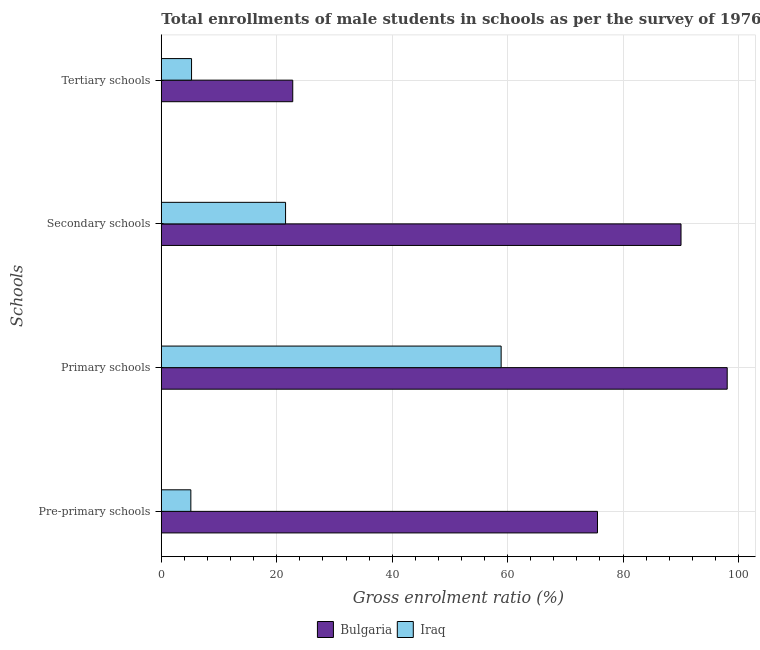How many different coloured bars are there?
Make the answer very short. 2. Are the number of bars per tick equal to the number of legend labels?
Your answer should be very brief. Yes. How many bars are there on the 4th tick from the top?
Your response must be concise. 2. What is the label of the 3rd group of bars from the top?
Provide a short and direct response. Primary schools. What is the gross enrolment ratio(male) in secondary schools in Bulgaria?
Your answer should be compact. 90.04. Across all countries, what is the maximum gross enrolment ratio(male) in tertiary schools?
Give a very brief answer. 22.77. Across all countries, what is the minimum gross enrolment ratio(male) in pre-primary schools?
Give a very brief answer. 5.12. In which country was the gross enrolment ratio(male) in pre-primary schools maximum?
Your response must be concise. Bulgaria. In which country was the gross enrolment ratio(male) in tertiary schools minimum?
Provide a short and direct response. Iraq. What is the total gross enrolment ratio(male) in pre-primary schools in the graph?
Offer a very short reply. 80.69. What is the difference between the gross enrolment ratio(male) in tertiary schools in Iraq and that in Bulgaria?
Your answer should be compact. -17.53. What is the difference between the gross enrolment ratio(male) in primary schools in Bulgaria and the gross enrolment ratio(male) in secondary schools in Iraq?
Your answer should be compact. 76.52. What is the average gross enrolment ratio(male) in secondary schools per country?
Offer a terse response. 55.79. What is the difference between the gross enrolment ratio(male) in tertiary schools and gross enrolment ratio(male) in pre-primary schools in Iraq?
Give a very brief answer. 0.12. What is the ratio of the gross enrolment ratio(male) in pre-primary schools in Bulgaria to that in Iraq?
Make the answer very short. 14.77. Is the difference between the gross enrolment ratio(male) in pre-primary schools in Iraq and Bulgaria greater than the difference between the gross enrolment ratio(male) in tertiary schools in Iraq and Bulgaria?
Give a very brief answer. No. What is the difference between the highest and the second highest gross enrolment ratio(male) in tertiary schools?
Offer a terse response. 17.53. What is the difference between the highest and the lowest gross enrolment ratio(male) in pre-primary schools?
Ensure brevity in your answer.  70.45. In how many countries, is the gross enrolment ratio(male) in primary schools greater than the average gross enrolment ratio(male) in primary schools taken over all countries?
Make the answer very short. 1. Is it the case that in every country, the sum of the gross enrolment ratio(male) in pre-primary schools and gross enrolment ratio(male) in primary schools is greater than the sum of gross enrolment ratio(male) in tertiary schools and gross enrolment ratio(male) in secondary schools?
Give a very brief answer. Yes. Is it the case that in every country, the sum of the gross enrolment ratio(male) in pre-primary schools and gross enrolment ratio(male) in primary schools is greater than the gross enrolment ratio(male) in secondary schools?
Your response must be concise. Yes. How many bars are there?
Offer a terse response. 8. How many countries are there in the graph?
Provide a short and direct response. 2. What is the difference between two consecutive major ticks on the X-axis?
Offer a terse response. 20. Are the values on the major ticks of X-axis written in scientific E-notation?
Ensure brevity in your answer.  No. Does the graph contain any zero values?
Provide a succinct answer. No. Does the graph contain grids?
Your answer should be very brief. Yes. Where does the legend appear in the graph?
Make the answer very short. Bottom center. How many legend labels are there?
Your answer should be very brief. 2. What is the title of the graph?
Provide a succinct answer. Total enrollments of male students in schools as per the survey of 1976 conducted in different countries. Does "Channel Islands" appear as one of the legend labels in the graph?
Provide a succinct answer. No. What is the label or title of the X-axis?
Provide a short and direct response. Gross enrolment ratio (%). What is the label or title of the Y-axis?
Provide a short and direct response. Schools. What is the Gross enrolment ratio (%) of Bulgaria in Pre-primary schools?
Make the answer very short. 75.57. What is the Gross enrolment ratio (%) of Iraq in Pre-primary schools?
Ensure brevity in your answer.  5.12. What is the Gross enrolment ratio (%) in Bulgaria in Primary schools?
Offer a very short reply. 98.04. What is the Gross enrolment ratio (%) in Iraq in Primary schools?
Provide a short and direct response. 58.88. What is the Gross enrolment ratio (%) of Bulgaria in Secondary schools?
Your response must be concise. 90.04. What is the Gross enrolment ratio (%) in Iraq in Secondary schools?
Offer a terse response. 21.53. What is the Gross enrolment ratio (%) of Bulgaria in Tertiary schools?
Provide a short and direct response. 22.77. What is the Gross enrolment ratio (%) in Iraq in Tertiary schools?
Make the answer very short. 5.24. Across all Schools, what is the maximum Gross enrolment ratio (%) of Bulgaria?
Provide a succinct answer. 98.04. Across all Schools, what is the maximum Gross enrolment ratio (%) in Iraq?
Keep it short and to the point. 58.88. Across all Schools, what is the minimum Gross enrolment ratio (%) of Bulgaria?
Keep it short and to the point. 22.77. Across all Schools, what is the minimum Gross enrolment ratio (%) in Iraq?
Your response must be concise. 5.12. What is the total Gross enrolment ratio (%) of Bulgaria in the graph?
Ensure brevity in your answer.  286.43. What is the total Gross enrolment ratio (%) of Iraq in the graph?
Make the answer very short. 90.76. What is the difference between the Gross enrolment ratio (%) of Bulgaria in Pre-primary schools and that in Primary schools?
Your response must be concise. -22.47. What is the difference between the Gross enrolment ratio (%) in Iraq in Pre-primary schools and that in Primary schools?
Your answer should be compact. -53.76. What is the difference between the Gross enrolment ratio (%) in Bulgaria in Pre-primary schools and that in Secondary schools?
Provide a short and direct response. -14.47. What is the difference between the Gross enrolment ratio (%) in Iraq in Pre-primary schools and that in Secondary schools?
Provide a succinct answer. -16.41. What is the difference between the Gross enrolment ratio (%) of Bulgaria in Pre-primary schools and that in Tertiary schools?
Make the answer very short. 52.8. What is the difference between the Gross enrolment ratio (%) of Iraq in Pre-primary schools and that in Tertiary schools?
Keep it short and to the point. -0.12. What is the difference between the Gross enrolment ratio (%) in Bulgaria in Primary schools and that in Secondary schools?
Keep it short and to the point. 8. What is the difference between the Gross enrolment ratio (%) in Iraq in Primary schools and that in Secondary schools?
Ensure brevity in your answer.  37.35. What is the difference between the Gross enrolment ratio (%) of Bulgaria in Primary schools and that in Tertiary schools?
Keep it short and to the point. 75.27. What is the difference between the Gross enrolment ratio (%) of Iraq in Primary schools and that in Tertiary schools?
Provide a succinct answer. 53.64. What is the difference between the Gross enrolment ratio (%) in Bulgaria in Secondary schools and that in Tertiary schools?
Offer a very short reply. 67.27. What is the difference between the Gross enrolment ratio (%) of Iraq in Secondary schools and that in Tertiary schools?
Provide a succinct answer. 16.29. What is the difference between the Gross enrolment ratio (%) of Bulgaria in Pre-primary schools and the Gross enrolment ratio (%) of Iraq in Primary schools?
Ensure brevity in your answer.  16.69. What is the difference between the Gross enrolment ratio (%) in Bulgaria in Pre-primary schools and the Gross enrolment ratio (%) in Iraq in Secondary schools?
Your answer should be very brief. 54.04. What is the difference between the Gross enrolment ratio (%) in Bulgaria in Pre-primary schools and the Gross enrolment ratio (%) in Iraq in Tertiary schools?
Offer a terse response. 70.33. What is the difference between the Gross enrolment ratio (%) in Bulgaria in Primary schools and the Gross enrolment ratio (%) in Iraq in Secondary schools?
Your answer should be compact. 76.52. What is the difference between the Gross enrolment ratio (%) of Bulgaria in Primary schools and the Gross enrolment ratio (%) of Iraq in Tertiary schools?
Your answer should be very brief. 92.81. What is the difference between the Gross enrolment ratio (%) of Bulgaria in Secondary schools and the Gross enrolment ratio (%) of Iraq in Tertiary schools?
Provide a short and direct response. 84.81. What is the average Gross enrolment ratio (%) of Bulgaria per Schools?
Provide a short and direct response. 71.61. What is the average Gross enrolment ratio (%) in Iraq per Schools?
Ensure brevity in your answer.  22.69. What is the difference between the Gross enrolment ratio (%) of Bulgaria and Gross enrolment ratio (%) of Iraq in Pre-primary schools?
Your answer should be very brief. 70.45. What is the difference between the Gross enrolment ratio (%) of Bulgaria and Gross enrolment ratio (%) of Iraq in Primary schools?
Offer a very short reply. 39.17. What is the difference between the Gross enrolment ratio (%) of Bulgaria and Gross enrolment ratio (%) of Iraq in Secondary schools?
Your response must be concise. 68.52. What is the difference between the Gross enrolment ratio (%) of Bulgaria and Gross enrolment ratio (%) of Iraq in Tertiary schools?
Keep it short and to the point. 17.53. What is the ratio of the Gross enrolment ratio (%) in Bulgaria in Pre-primary schools to that in Primary schools?
Keep it short and to the point. 0.77. What is the ratio of the Gross enrolment ratio (%) in Iraq in Pre-primary schools to that in Primary schools?
Provide a short and direct response. 0.09. What is the ratio of the Gross enrolment ratio (%) in Bulgaria in Pre-primary schools to that in Secondary schools?
Your answer should be compact. 0.84. What is the ratio of the Gross enrolment ratio (%) in Iraq in Pre-primary schools to that in Secondary schools?
Your response must be concise. 0.24. What is the ratio of the Gross enrolment ratio (%) of Bulgaria in Pre-primary schools to that in Tertiary schools?
Your answer should be compact. 3.32. What is the ratio of the Gross enrolment ratio (%) of Iraq in Pre-primary schools to that in Tertiary schools?
Offer a terse response. 0.98. What is the ratio of the Gross enrolment ratio (%) of Bulgaria in Primary schools to that in Secondary schools?
Your answer should be compact. 1.09. What is the ratio of the Gross enrolment ratio (%) of Iraq in Primary schools to that in Secondary schools?
Offer a very short reply. 2.73. What is the ratio of the Gross enrolment ratio (%) of Bulgaria in Primary schools to that in Tertiary schools?
Offer a very short reply. 4.31. What is the ratio of the Gross enrolment ratio (%) in Iraq in Primary schools to that in Tertiary schools?
Provide a succinct answer. 11.24. What is the ratio of the Gross enrolment ratio (%) in Bulgaria in Secondary schools to that in Tertiary schools?
Give a very brief answer. 3.95. What is the ratio of the Gross enrolment ratio (%) of Iraq in Secondary schools to that in Tertiary schools?
Provide a short and direct response. 4.11. What is the difference between the highest and the second highest Gross enrolment ratio (%) of Bulgaria?
Offer a terse response. 8. What is the difference between the highest and the second highest Gross enrolment ratio (%) of Iraq?
Your answer should be compact. 37.35. What is the difference between the highest and the lowest Gross enrolment ratio (%) of Bulgaria?
Provide a short and direct response. 75.27. What is the difference between the highest and the lowest Gross enrolment ratio (%) in Iraq?
Your answer should be very brief. 53.76. 